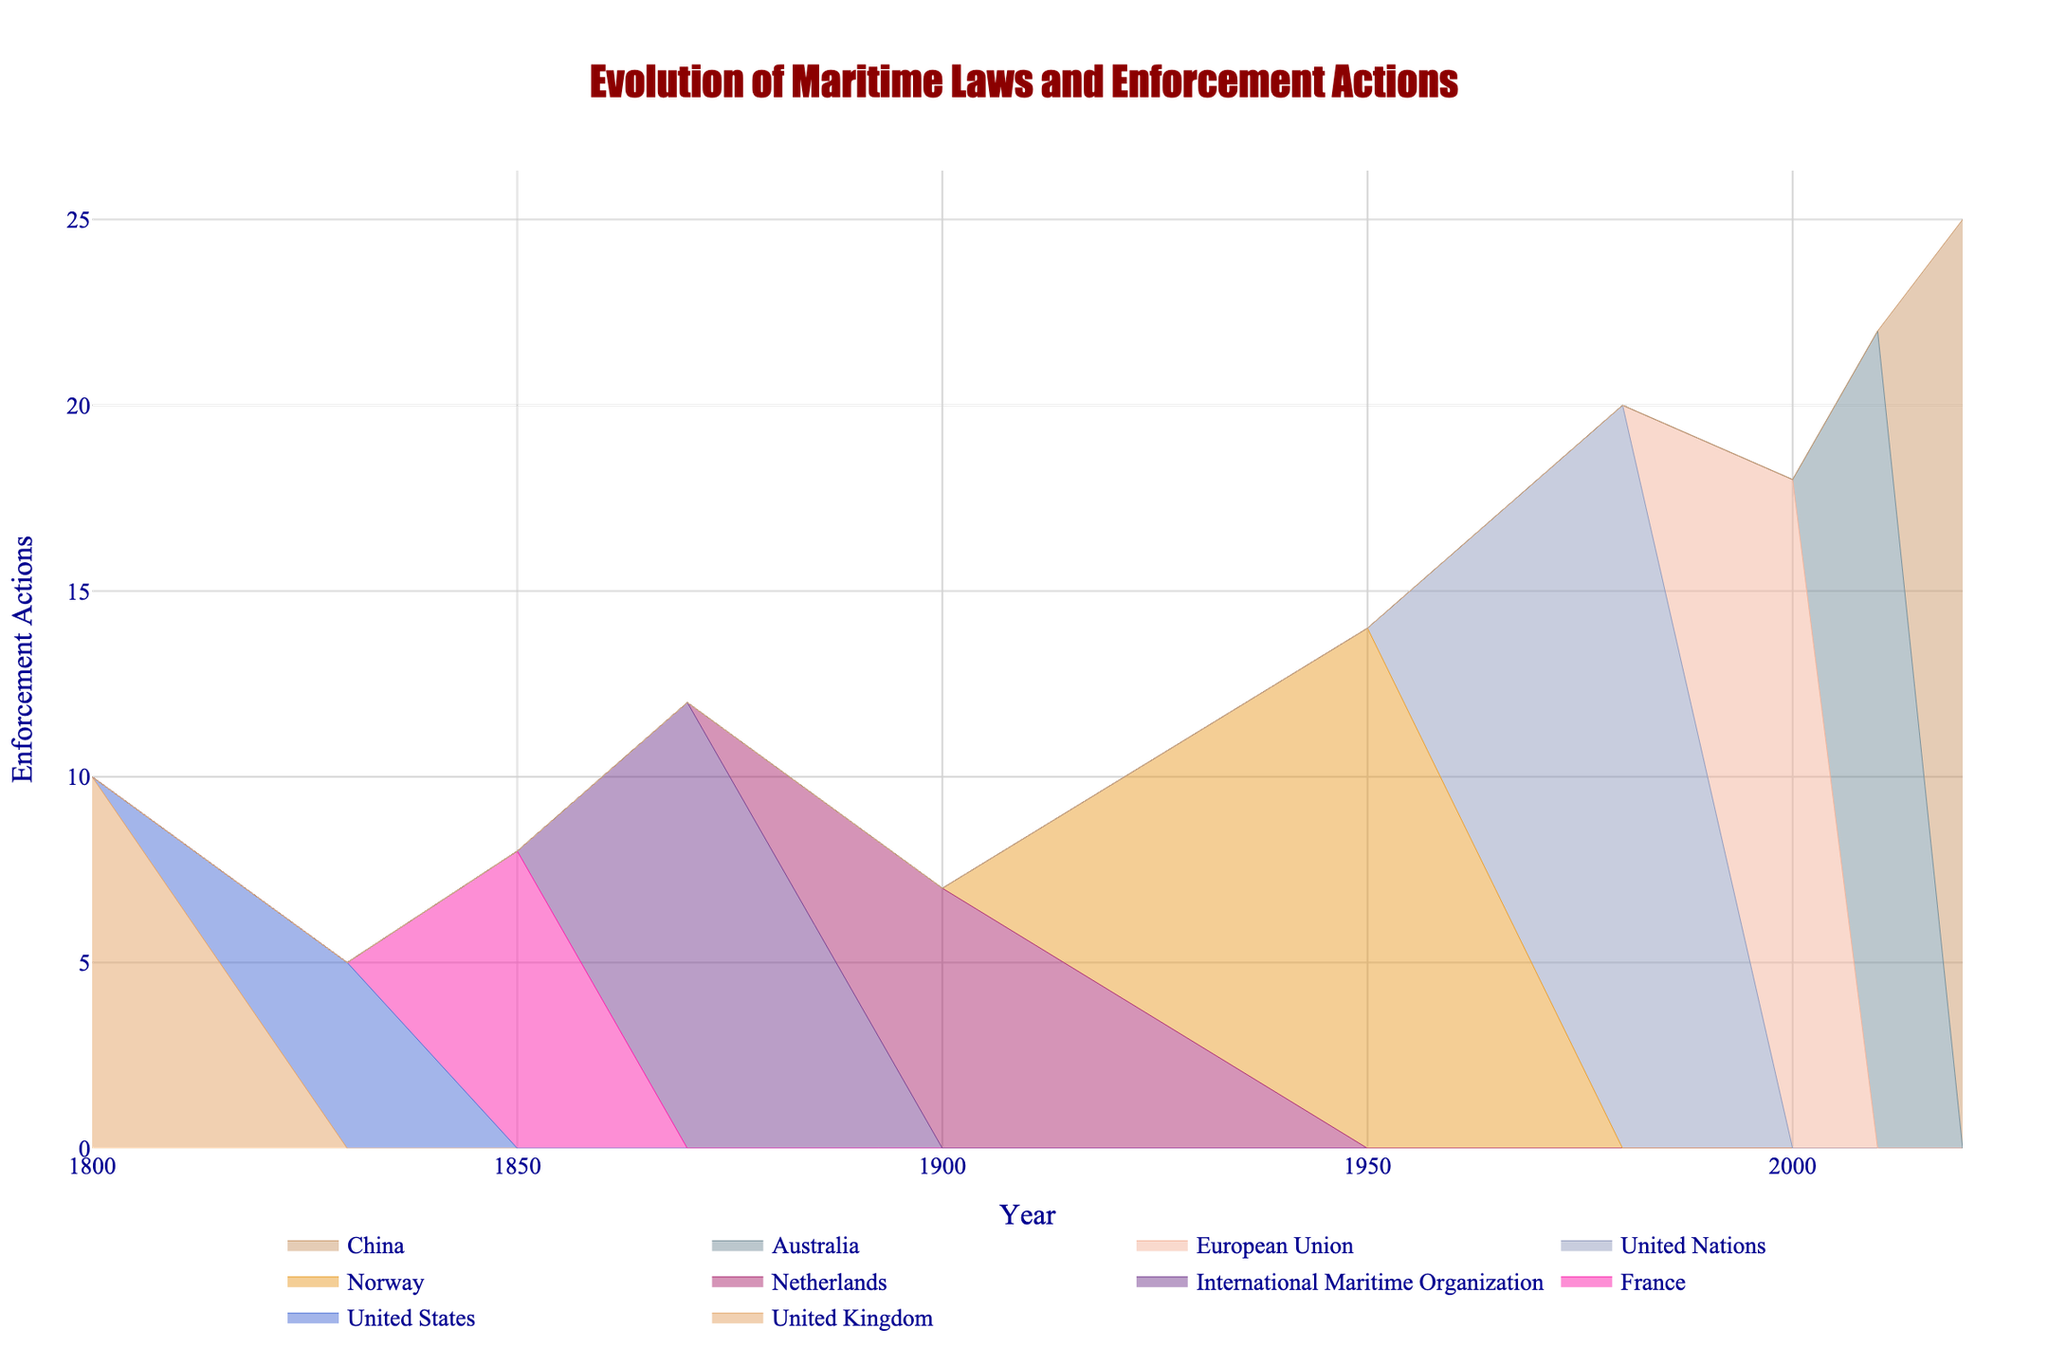When does the "United Nations Convention on the Law of the Sea (UNCLOS)" appear on the graph? The "United Nations Convention on the Law of the Sea (UNCLOS)" appears in the year column. Looking at the plot's hover info, it’s around 1980.
Answer: 1980 Which organization had the highest number of enforcement actions in 2020? Observing the data points for the year 2020, the enforcement actions by different organizations are represented. The point with the highest value is associated with China.
Answer: China Compare the enforcement actions by the United Kingdom in 1800 and the United States in 1830. Which one is higher and by how much? The figure shows values for enforcement actions. Comparing the points, the United Kingdom has 10 actions in 1800, and the United States has 5 in 1830. The United Kingdom's actions are higher by 5.
Answer: United Kingdom, by 5 What is the general trend of enforcement actions over time? Observing the figure from left to right (from 1800 to 2020), there is an upward trend in the enforcement actions, indicating an increase over time.
Answer: Increasing Between which consecutive years did the largest increase in enforcement actions occur? By examining the consecutive data points along the x-axis and their corresponding y-values, the largest jump can be visualized between 1980 (United Nations) and 2000 (European Union), increasing from 20 to 18.
Answer: 1980 to 2000 How many organizations have introduced regulations between 1900 and 1950? Checking the figure for the range between 1900 and 1950, there are data points for the Netherlands in 1900 and Norway in 1950. This means two organizations.
Answer: 2 Which organization had the latest regulation introduction on the graph? The latest regulation can be identified at the farthest right side of the x-axis. It corresponds to China in 2020.
Answer: China What is the difference in enforcement actions between Australia in 2010 and the European Union in 2000? The y-values allow the comparison for respective years. Australia has 22 enforcement actions in 2010, and the European Union has 18 in 2000. The difference is 22 - 18, which is 4.
Answer: 4 How many years apart are the regulations introduced by France and Norway? Looking at the respective points for France (1850) and Norway (1950), the difference in years is calculated as 1950 - 1850.
Answer: 100 What pattern can you see in the colors of the lines representing different organizations? Observing the lines' colors, each organization's data is represented in unique colors drawn from a spectrum, providing differentiation and clarity.
Answer: Unique colors for each organization 